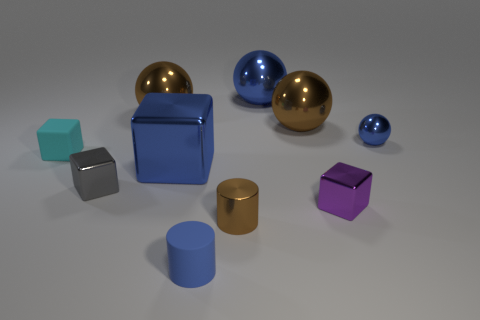Subtract all balls. How many objects are left? 6 Subtract all rubber objects. Subtract all large metallic spheres. How many objects are left? 5 Add 5 small cylinders. How many small cylinders are left? 7 Add 2 big objects. How many big objects exist? 6 Subtract 0 cyan spheres. How many objects are left? 10 